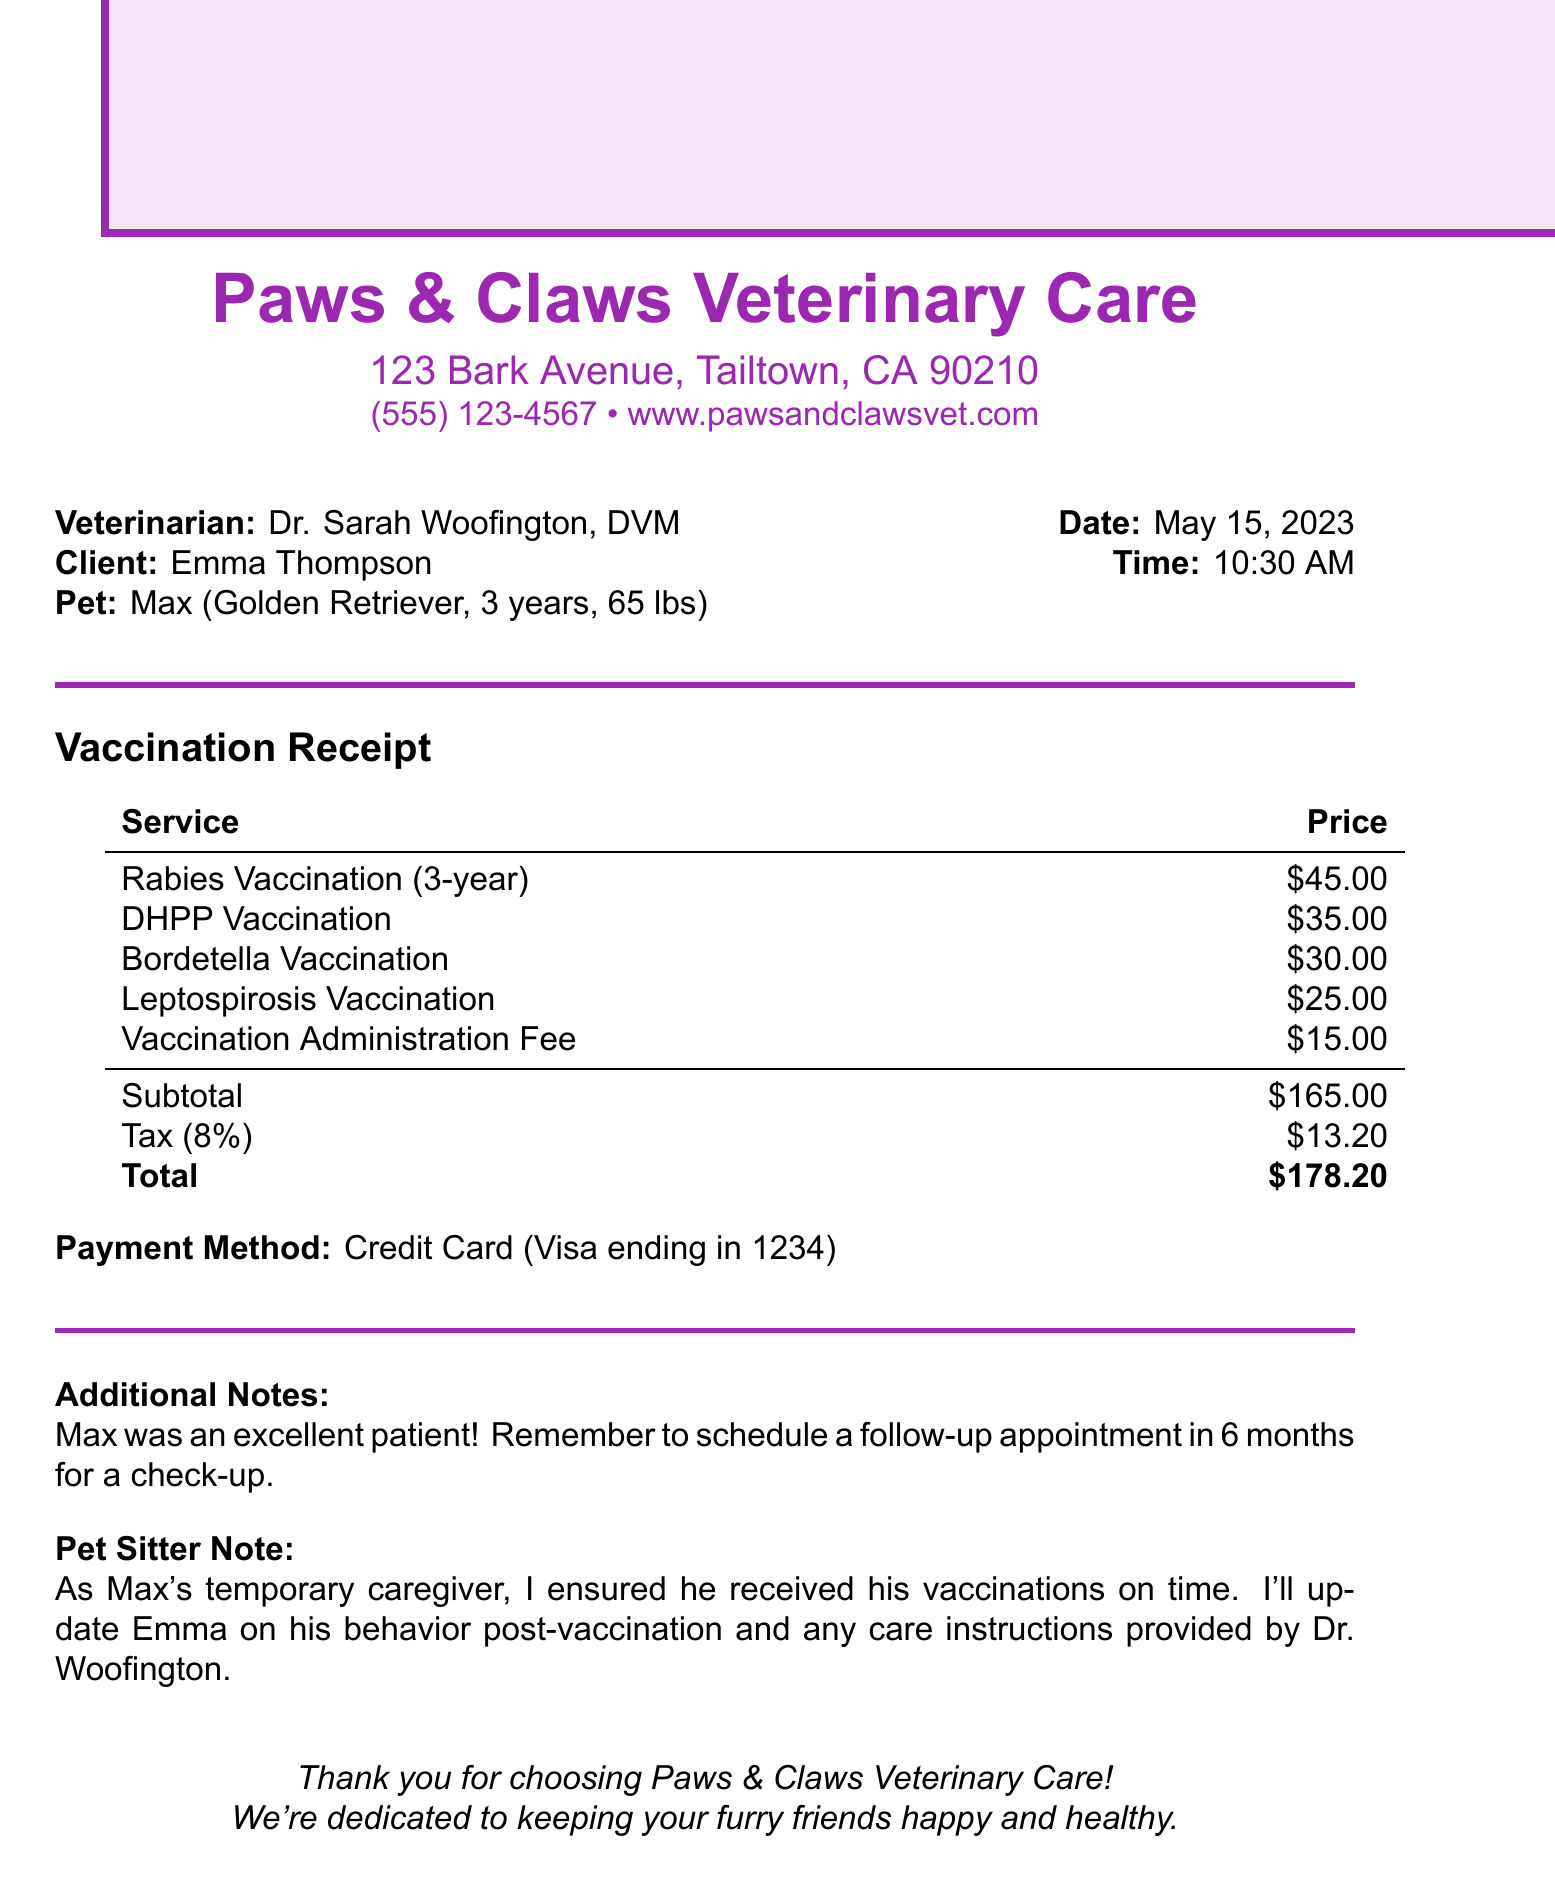What is the name of the veterinary clinic? The name of the veterinary clinic is mentioned at the top of the document.
Answer: Paws & Claws Veterinary Care Who is the veterinarian? The veterinarian's name is provided in the document as part of the clinic's information.
Answer: Dr. Sarah Woofington, DVM What vaccinations did Max receive? The document lists all the vaccinations administered to Max under the service section.
Answer: Rabies, DHPP, Bordetella, Leptospirosis What is the total amount charged? The total amount is calculated and summarized at the end of the receipt.
Answer: $178.20 How much is the Rabies Vaccination? The price for each vaccination can be found in the services table of the document.
Answer: $45.00 What is the subtotal before tax? The subtotal is clearly stated in the totals section before taxes are added.
Answer: $165.00 When should the follow-up appointment be scheduled? The document mentions when a follow-up appointment should be scheduled in the additional notes.
Answer: In 6 months What payment method was used? The payment method is specified in the payment details section of the document.
Answer: Credit Card (Visa ending in 1234) 